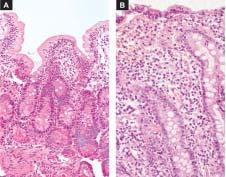s the basement membrane shortening and blunting of the villi with reduction in their height?
Answer the question using a single word or phrase. No 